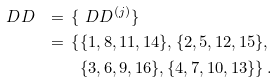Convert formula to latex. <formula><loc_0><loc_0><loc_500><loc_500>\ D D _ { \ } = \, \{ & \ D D _ { \ } ^ { ( j ) } \} \\ = \, \{ & \{ 1 , 8 , 1 1 , 1 4 \} , \{ 2 , 5 , 1 2 , 1 5 \} , \\ & \{ 3 , 6 , 9 , 1 6 \} , \{ 4 , 7 , 1 0 , 1 3 \} \} \, .</formula> 